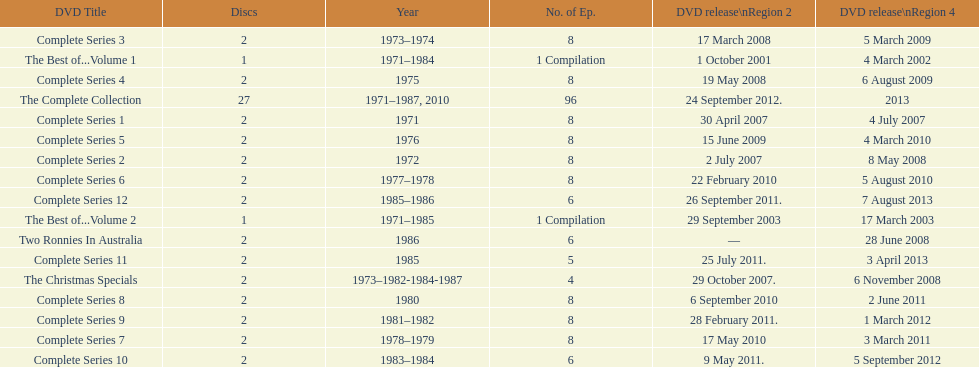What was the total number of seasons for "the two ronnies" television show? 12. 